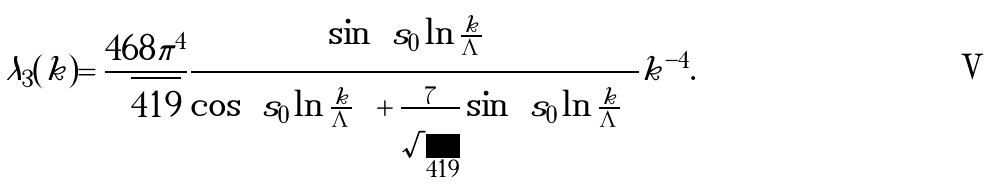Convert formula to latex. <formula><loc_0><loc_0><loc_500><loc_500>\lambda _ { 3 } ( k ) = \frac { 4 6 8 \pi ^ { 4 } } { \sqrt { 4 1 9 } } \frac { \sin \left ( s _ { 0 } \ln \frac { k } { \Lambda } \right ) } { \cos \left ( s _ { 0 } \ln \frac { k } { \Lambda } \right ) + \frac { 7 } { \sqrt { 4 1 9 } } \sin \left ( s _ { 0 } \ln \frac { k } { \Lambda } \right ) } k ^ { - 4 } .</formula> 